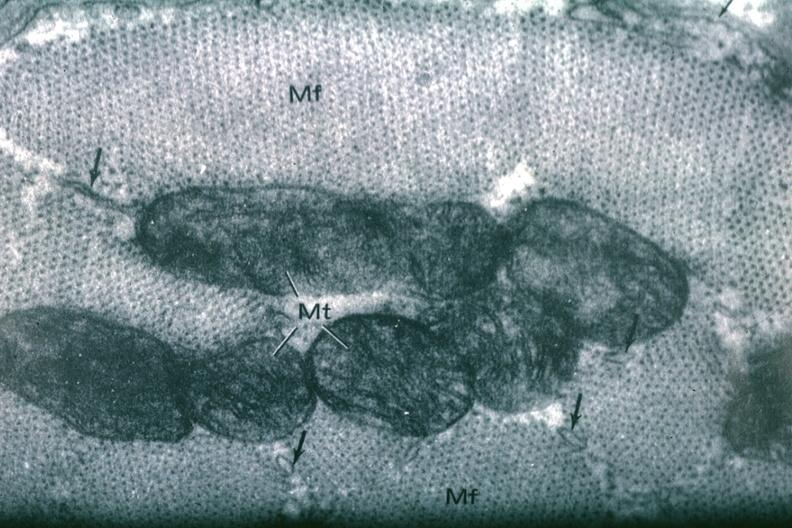s infant body present?
Answer the question using a single word or phrase. No 